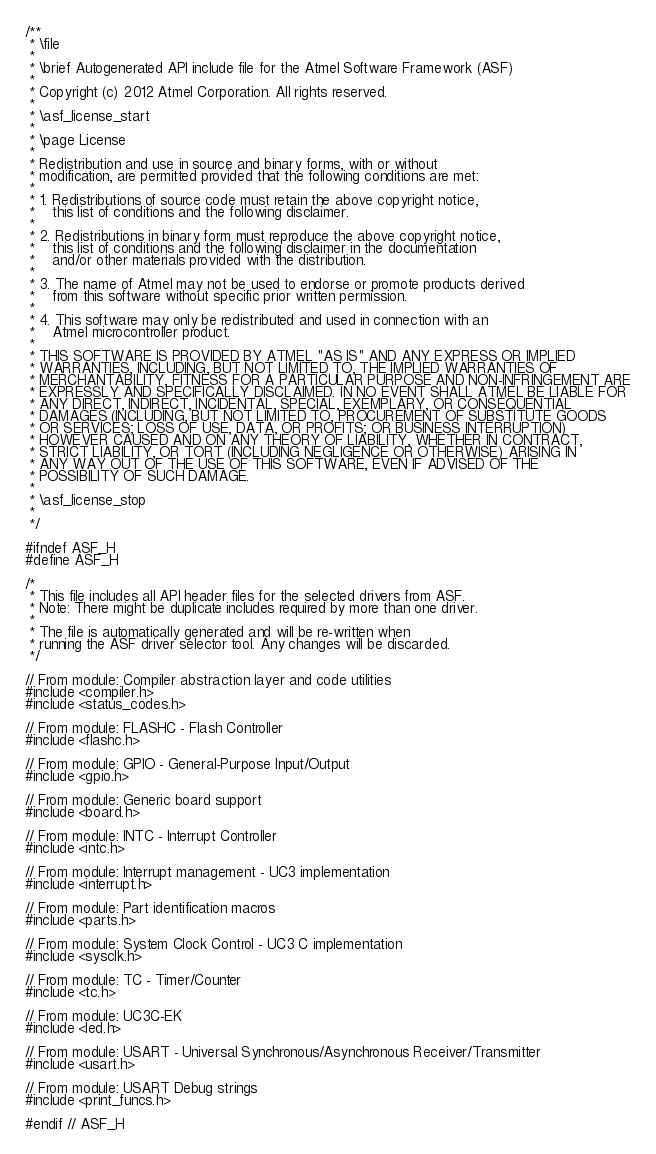Convert code to text. <code><loc_0><loc_0><loc_500><loc_500><_C_>/**
 * \file
 *
 * \brief Autogenerated API include file for the Atmel Software Framework (ASF)
 *
 * Copyright (c) 2012 Atmel Corporation. All rights reserved.
 *
 * \asf_license_start
 *
 * \page License
 *
 * Redistribution and use in source and binary forms, with or without
 * modification, are permitted provided that the following conditions are met:
 *
 * 1. Redistributions of source code must retain the above copyright notice,
 *    this list of conditions and the following disclaimer.
 *
 * 2. Redistributions in binary form must reproduce the above copyright notice,
 *    this list of conditions and the following disclaimer in the documentation
 *    and/or other materials provided with the distribution.
 *
 * 3. The name of Atmel may not be used to endorse or promote products derived
 *    from this software without specific prior written permission.
 *
 * 4. This software may only be redistributed and used in connection with an
 *    Atmel microcontroller product.
 *
 * THIS SOFTWARE IS PROVIDED BY ATMEL "AS IS" AND ANY EXPRESS OR IMPLIED
 * WARRANTIES, INCLUDING, BUT NOT LIMITED TO, THE IMPLIED WARRANTIES OF
 * MERCHANTABILITY, FITNESS FOR A PARTICULAR PURPOSE AND NON-INFRINGEMENT ARE
 * EXPRESSLY AND SPECIFICALLY DISCLAIMED. IN NO EVENT SHALL ATMEL BE LIABLE FOR
 * ANY DIRECT, INDIRECT, INCIDENTAL, SPECIAL, EXEMPLARY, OR CONSEQUENTIAL
 * DAMAGES (INCLUDING, BUT NOT LIMITED TO, PROCUREMENT OF SUBSTITUTE GOODS
 * OR SERVICES; LOSS OF USE, DATA, OR PROFITS; OR BUSINESS INTERRUPTION)
 * HOWEVER CAUSED AND ON ANY THEORY OF LIABILITY, WHETHER IN CONTRACT,
 * STRICT LIABILITY, OR TORT (INCLUDING NEGLIGENCE OR OTHERWISE) ARISING IN
 * ANY WAY OUT OF THE USE OF THIS SOFTWARE, EVEN IF ADVISED OF THE
 * POSSIBILITY OF SUCH DAMAGE.
 *
 * \asf_license_stop
 *
 */

#ifndef ASF_H
#define ASF_H

/*
 * This file includes all API header files for the selected drivers from ASF.
 * Note: There might be duplicate includes required by more than one driver.
 *
 * The file is automatically generated and will be re-written when
 * running the ASF driver selector tool. Any changes will be discarded.
 */

// From module: Compiler abstraction layer and code utilities
#include <compiler.h>
#include <status_codes.h>

// From module: FLASHC - Flash Controller
#include <flashc.h>

// From module: GPIO - General-Purpose Input/Output
#include <gpio.h>

// From module: Generic board support
#include <board.h>

// From module: INTC - Interrupt Controller
#include <intc.h>

// From module: Interrupt management - UC3 implementation
#include <interrupt.h>

// From module: Part identification macros
#include <parts.h>

// From module: System Clock Control - UC3 C implementation
#include <sysclk.h>

// From module: TC - Timer/Counter
#include <tc.h>

// From module: UC3C-EK
#include <led.h>

// From module: USART - Universal Synchronous/Asynchronous Receiver/Transmitter
#include <usart.h>

// From module: USART Debug strings
#include <print_funcs.h>

#endif // ASF_H
</code> 